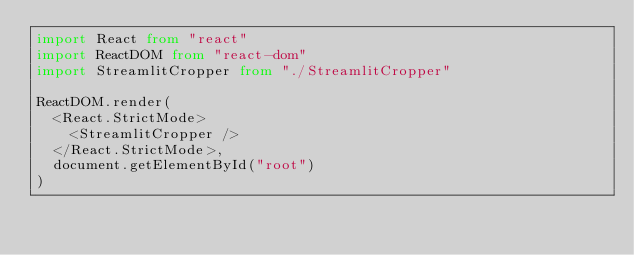Convert code to text. <code><loc_0><loc_0><loc_500><loc_500><_TypeScript_>import React from "react"
import ReactDOM from "react-dom"
import StreamlitCropper from "./StreamlitCropper"

ReactDOM.render(
  <React.StrictMode>
    <StreamlitCropper />
  </React.StrictMode>,
  document.getElementById("root")
)
</code> 